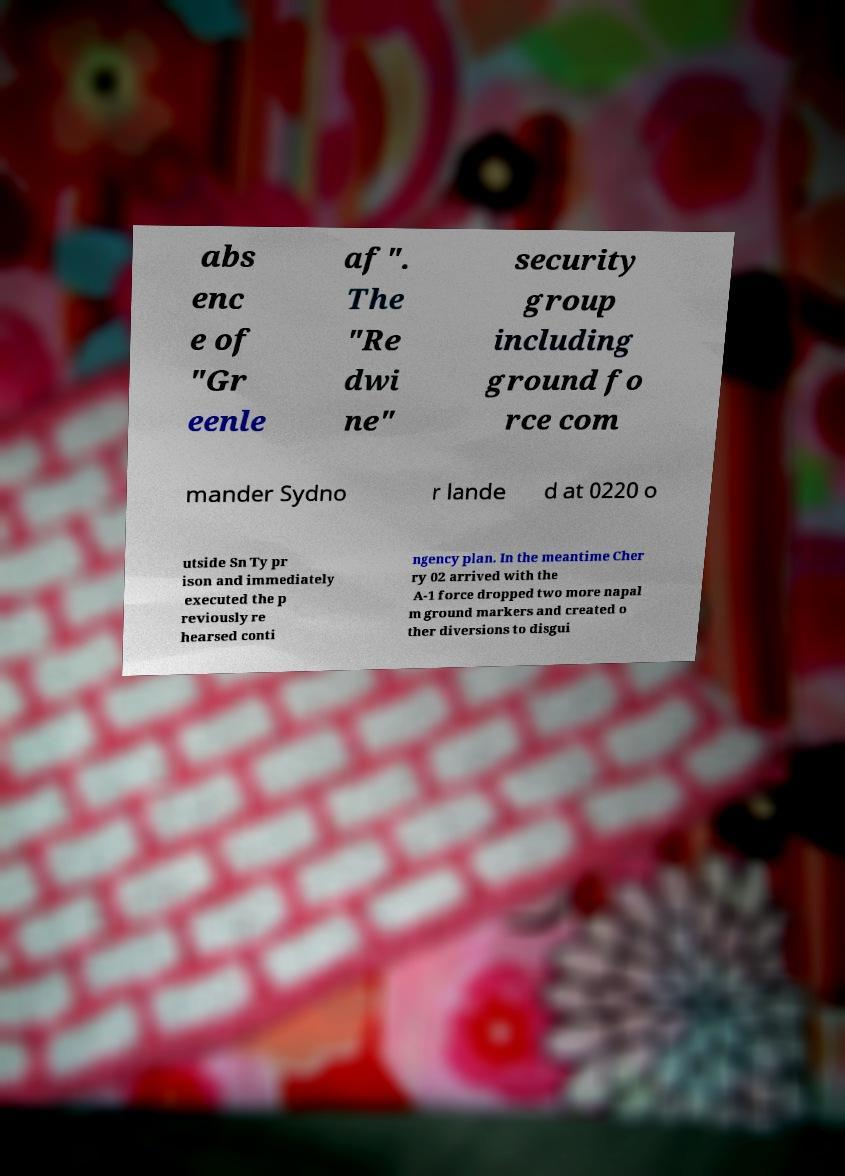For documentation purposes, I need the text within this image transcribed. Could you provide that? abs enc e of "Gr eenle af". The "Re dwi ne" security group including ground fo rce com mander Sydno r lande d at 0220 o utside Sn Ty pr ison and immediately executed the p reviously re hearsed conti ngency plan. In the meantime Cher ry 02 arrived with the A-1 force dropped two more napal m ground markers and created o ther diversions to disgui 